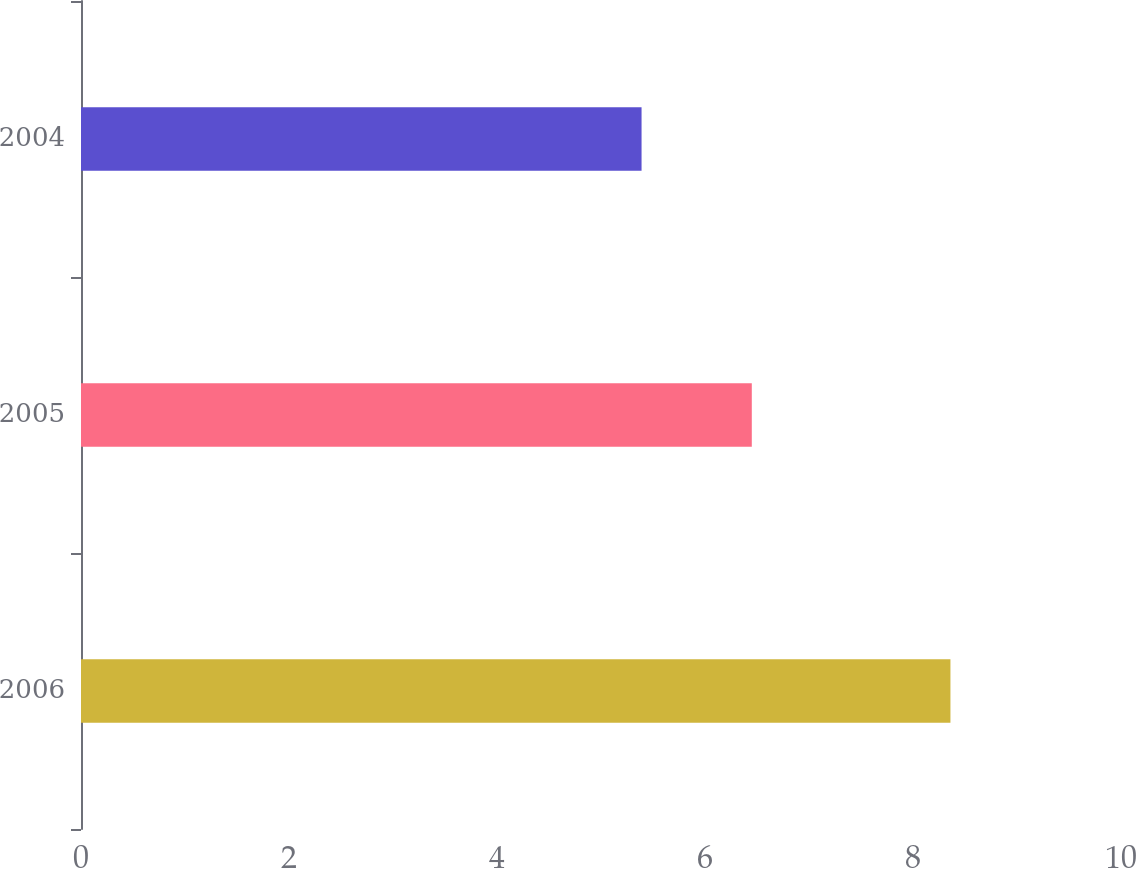<chart> <loc_0><loc_0><loc_500><loc_500><bar_chart><fcel>2006<fcel>2005<fcel>2004<nl><fcel>8.36<fcel>6.45<fcel>5.39<nl></chart> 